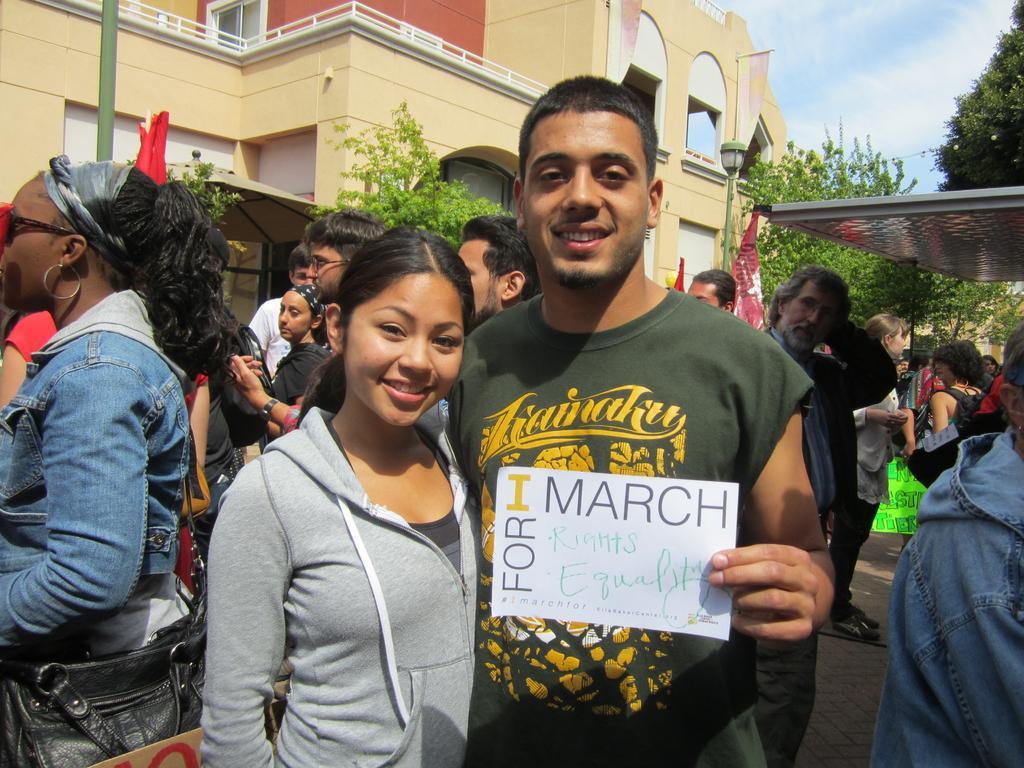Describe this image in one or two sentences. In this picture we can see some people standing here, a man on the right side is holding a paper, in the background there are some trees, we can see a building here, there is sky at the right top of the picture. 